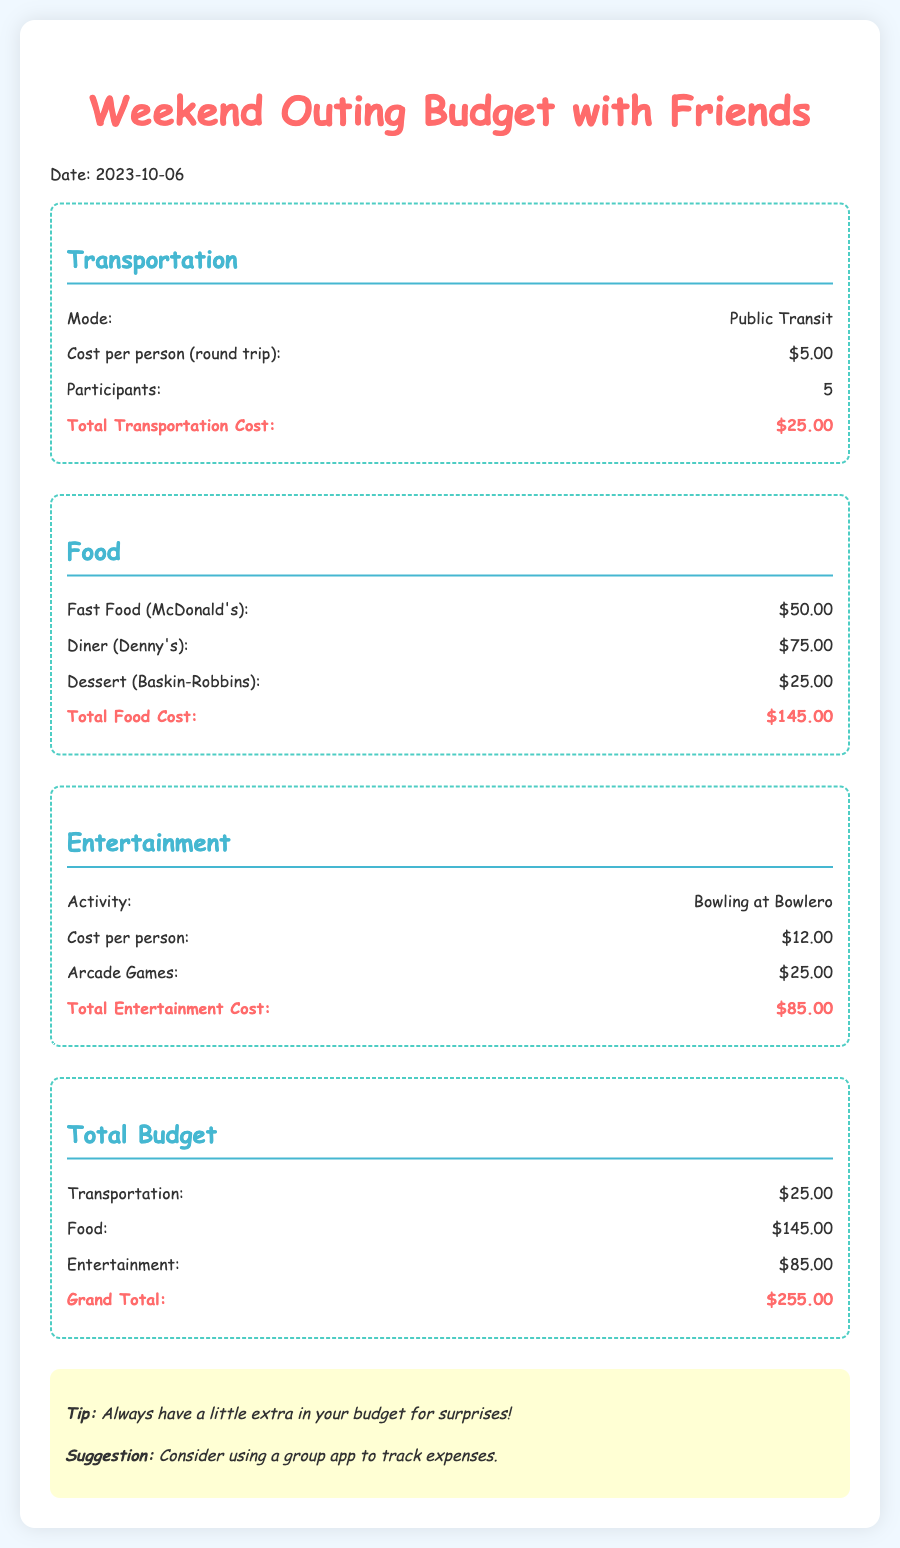What is the total transportation cost? The total transportation cost is listed in the budget section under Transportation, which is $25.00.
Answer: $25.00 How many participants are involved in the outing? The number of participants can be found in the Transportation section where it states there are 5 participants.
Answer: 5 What is the cost per person for bowling? The cost for bowling per person is specified in the Entertainment section as $12.00.
Answer: $12.00 What is the grand total for the outing? The grand total is calculated and presented in the Total Budget section, which sums the costs to $255.00.
Answer: $255.00 What type of food is included in the budget? The food types listed include Fast Food (McDonald's), Diner (Denny's), and Dessert (Baskin-Robbins) under the Food section.
Answer: Fast Food (McDonald's), Diner (Denny's), Dessert (Baskin-Robbins) What extra tip is provided in the document? The tip mentioned suggests always having a little extra in your budget for surprises, as noted in the notes section.
Answer: Always have a little extra in your budget for surprises! 